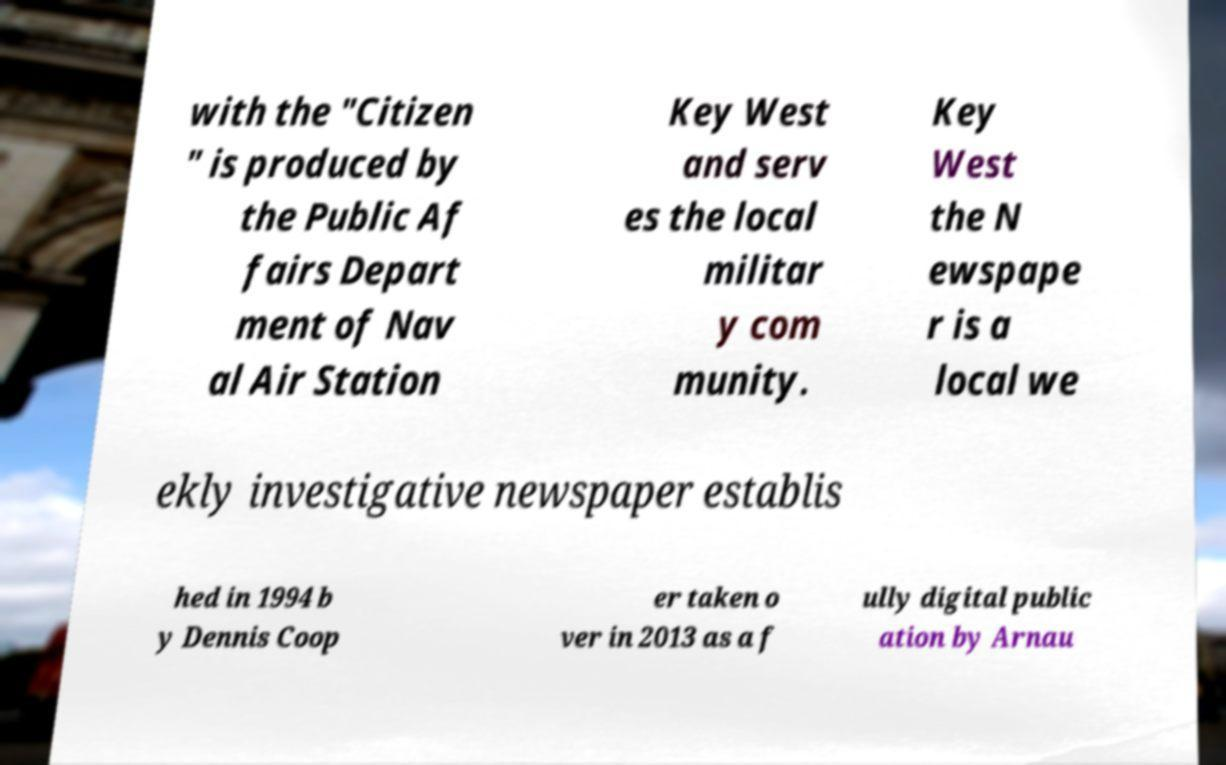I need the written content from this picture converted into text. Can you do that? with the "Citizen " is produced by the Public Af fairs Depart ment of Nav al Air Station Key West and serv es the local militar y com munity. Key West the N ewspape r is a local we ekly investigative newspaper establis hed in 1994 b y Dennis Coop er taken o ver in 2013 as a f ully digital public ation by Arnau 